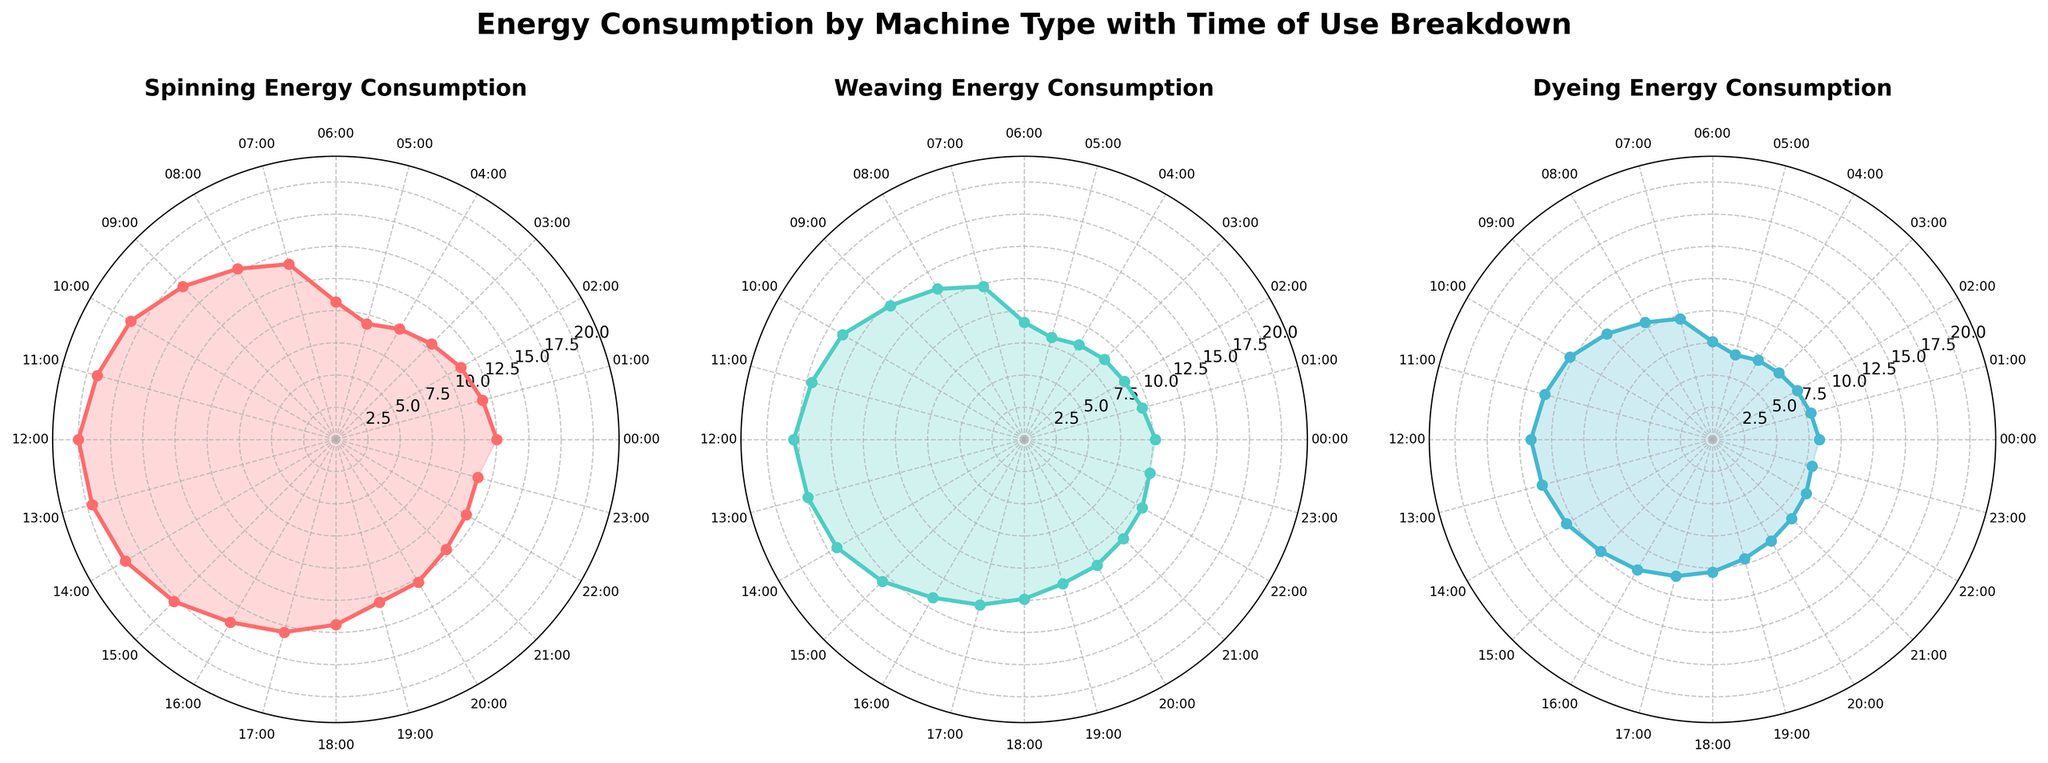What's the title of the figure? The title of the figure is displayed at the top, centered, and in bold font. It reads: "Energy Consumption by Machine Type with Time of Use Breakdown".
Answer: Energy Consumption by Machine Type with Time of Use Breakdown How many machine types are represented in the figure? The figure displays three subplots, each corresponding to a different machine type. These are shown in the titles of the subplots.
Answer: 3 Which machine type has the highest peak energy consumption? By observing the radial distances of the plots, the machine type with the highest peak energy consumption is identified. The peak is higher in the subplot for "Spinning".
Answer: Spinning At what time of day does the Dyeing machine type have its lowest energy consumption? For the Dyeing machine type subplot, observe the plot and identify the point with the smallest radial distance and match it to the corresponding time label. This occurs around 05:00-06:00.
Answer: 05:00-06:00 Compare the energy consumption at 12:00 for both the Spinning and Weaving machines. Which one is higher? Look at the radial distance of the plot points at 12:00 in both the Spinning and Weaving subplots. The consumption is higher for the Spinning machine at this time.
Answer: Spinning What is the range of energy consumption for the Weaving machine type? Observe the plot for the Weaving machine and identify the minimum and maximum energy values. The minimum is around 8.2 kWh and the maximum is around 17.9 kWh.
Answer: 8.2 kWh to 17.9 kWh During which hours does the Spinning machine type exceed 18 kWh consumption? Check the points on the Spinning subplot that are beyond the 18 kWh mark and note the corresponding time labels. This occurs from 10:00 to 13:00.
Answer: 10:00-13:00 Which time period has the most uniform energy consumption across all machine types? Compare the radial plot shapes of all three subplots to identify a time period where all three machines have nearly equal consumption. The period around 06:00-07:00 has nearly uniform consumption.
Answer: 06:00-07:00 Is the energy consumption pattern of the Dyeing machine more consistent compared to the other machine types? By looking at the smoothness and variation in the radial distances of the Dyeing subplot, it can be seen that Dyeing has less fluctuation compared to the Spinning and Weaving machines.
Answer: Yes Does any machine type have a consistent increase in energy consumption throughout the day? Observe the trendlines of each subplot to see if any machine type consistently increases in radial distance from 00:00 to 24:00. The energy consumption trend generally increases for the Spinning machine.
Answer: Yes, Spinning 